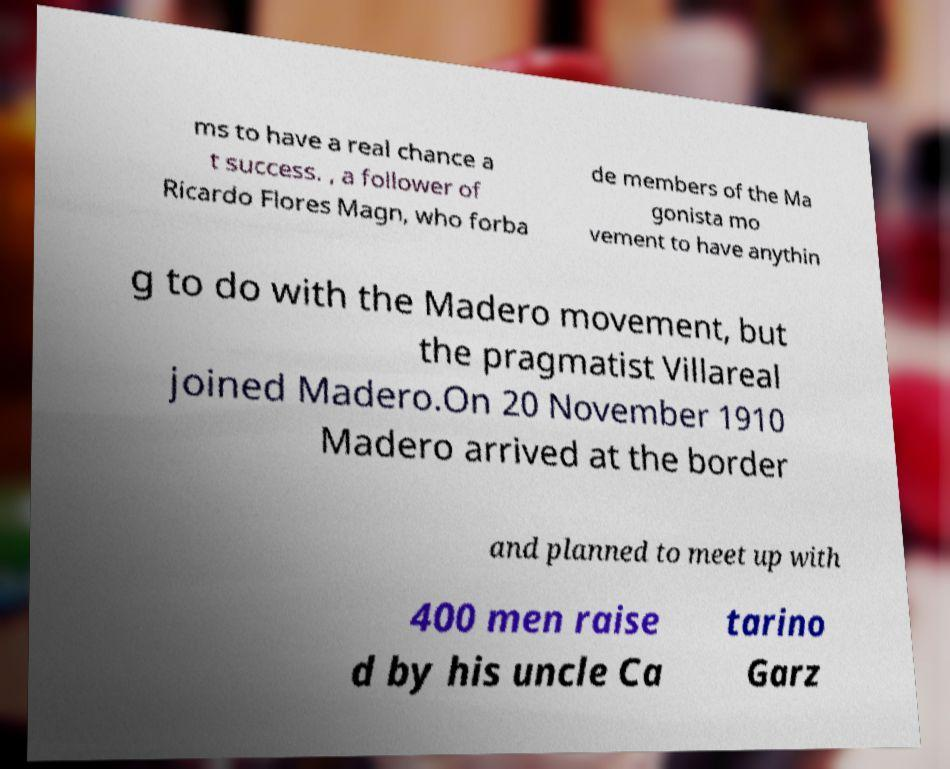For documentation purposes, I need the text within this image transcribed. Could you provide that? ms to have a real chance a t success. , a follower of Ricardo Flores Magn, who forba de members of the Ma gonista mo vement to have anythin g to do with the Madero movement, but the pragmatist Villareal joined Madero.On 20 November 1910 Madero arrived at the border and planned to meet up with 400 men raise d by his uncle Ca tarino Garz 